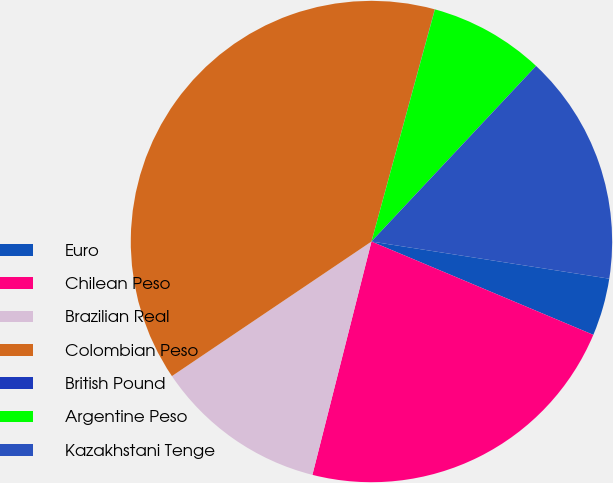Convert chart. <chart><loc_0><loc_0><loc_500><loc_500><pie_chart><fcel>Euro<fcel>Chilean Peso<fcel>Brazilian Real<fcel>Colombian Peso<fcel>British Pound<fcel>Argentine Peso<fcel>Kazakhstani Tenge<nl><fcel>3.87%<fcel>22.61%<fcel>11.61%<fcel>38.68%<fcel>0.01%<fcel>7.74%<fcel>15.48%<nl></chart> 